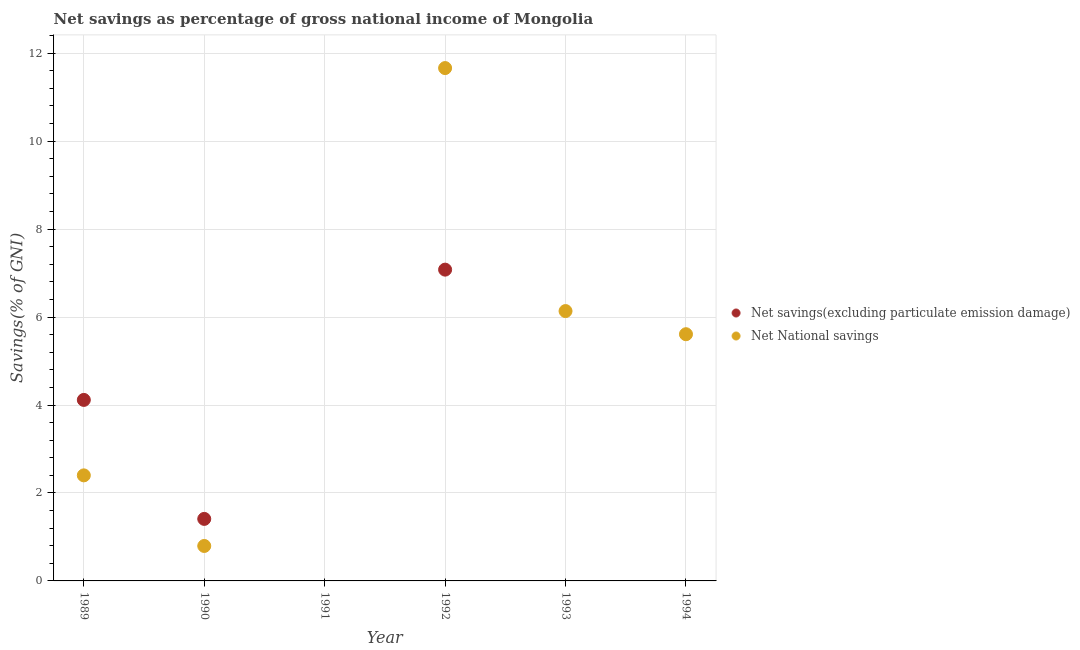Across all years, what is the maximum net savings(excluding particulate emission damage)?
Provide a succinct answer. 7.08. What is the total net national savings in the graph?
Your response must be concise. 26.6. What is the difference between the net national savings in 1990 and that in 1994?
Provide a short and direct response. -4.82. What is the difference between the net national savings in 1989 and the net savings(excluding particulate emission damage) in 1991?
Ensure brevity in your answer.  2.4. What is the average net savings(excluding particulate emission damage) per year?
Ensure brevity in your answer.  2.1. In the year 1992, what is the difference between the net national savings and net savings(excluding particulate emission damage)?
Your answer should be very brief. 4.58. In how many years, is the net national savings greater than 7.2 %?
Give a very brief answer. 1. What is the ratio of the net national savings in 1989 to that in 1992?
Your answer should be compact. 0.21. Is the net national savings in 1989 less than that in 1992?
Your answer should be compact. Yes. What is the difference between the highest and the second highest net savings(excluding particulate emission damage)?
Your answer should be very brief. 2.96. What is the difference between the highest and the lowest net national savings?
Your response must be concise. 11.66. In how many years, is the net national savings greater than the average net national savings taken over all years?
Make the answer very short. 3. Does the net savings(excluding particulate emission damage) monotonically increase over the years?
Your answer should be compact. No. How many dotlines are there?
Offer a terse response. 2. How many years are there in the graph?
Provide a succinct answer. 6. Are the values on the major ticks of Y-axis written in scientific E-notation?
Offer a very short reply. No. Does the graph contain grids?
Give a very brief answer. Yes. How many legend labels are there?
Make the answer very short. 2. What is the title of the graph?
Offer a very short reply. Net savings as percentage of gross national income of Mongolia. Does "% of gross capital formation" appear as one of the legend labels in the graph?
Keep it short and to the point. No. What is the label or title of the X-axis?
Ensure brevity in your answer.  Year. What is the label or title of the Y-axis?
Your answer should be compact. Savings(% of GNI). What is the Savings(% of GNI) of Net savings(excluding particulate emission damage) in 1989?
Provide a short and direct response. 4.12. What is the Savings(% of GNI) of Net National savings in 1989?
Your answer should be very brief. 2.4. What is the Savings(% of GNI) in Net savings(excluding particulate emission damage) in 1990?
Offer a terse response. 1.41. What is the Savings(% of GNI) of Net National savings in 1990?
Ensure brevity in your answer.  0.79. What is the Savings(% of GNI) of Net savings(excluding particulate emission damage) in 1991?
Offer a terse response. 0. What is the Savings(% of GNI) in Net savings(excluding particulate emission damage) in 1992?
Offer a terse response. 7.08. What is the Savings(% of GNI) of Net National savings in 1992?
Provide a short and direct response. 11.66. What is the Savings(% of GNI) in Net savings(excluding particulate emission damage) in 1993?
Your response must be concise. 0. What is the Savings(% of GNI) of Net National savings in 1993?
Keep it short and to the point. 6.14. What is the Savings(% of GNI) in Net savings(excluding particulate emission damage) in 1994?
Offer a very short reply. 0. What is the Savings(% of GNI) of Net National savings in 1994?
Offer a very short reply. 5.61. Across all years, what is the maximum Savings(% of GNI) of Net savings(excluding particulate emission damage)?
Keep it short and to the point. 7.08. Across all years, what is the maximum Savings(% of GNI) of Net National savings?
Give a very brief answer. 11.66. Across all years, what is the minimum Savings(% of GNI) of Net savings(excluding particulate emission damage)?
Offer a very short reply. 0. Across all years, what is the minimum Savings(% of GNI) in Net National savings?
Ensure brevity in your answer.  0. What is the total Savings(% of GNI) of Net savings(excluding particulate emission damage) in the graph?
Provide a short and direct response. 12.61. What is the total Savings(% of GNI) of Net National savings in the graph?
Provide a short and direct response. 26.6. What is the difference between the Savings(% of GNI) of Net savings(excluding particulate emission damage) in 1989 and that in 1990?
Provide a short and direct response. 2.71. What is the difference between the Savings(% of GNI) of Net National savings in 1989 and that in 1990?
Offer a terse response. 1.61. What is the difference between the Savings(% of GNI) in Net savings(excluding particulate emission damage) in 1989 and that in 1992?
Your answer should be compact. -2.96. What is the difference between the Savings(% of GNI) in Net National savings in 1989 and that in 1992?
Your answer should be compact. -9.26. What is the difference between the Savings(% of GNI) of Net National savings in 1989 and that in 1993?
Your answer should be very brief. -3.74. What is the difference between the Savings(% of GNI) of Net National savings in 1989 and that in 1994?
Offer a terse response. -3.21. What is the difference between the Savings(% of GNI) in Net savings(excluding particulate emission damage) in 1990 and that in 1992?
Keep it short and to the point. -5.67. What is the difference between the Savings(% of GNI) in Net National savings in 1990 and that in 1992?
Your answer should be very brief. -10.87. What is the difference between the Savings(% of GNI) of Net National savings in 1990 and that in 1993?
Provide a short and direct response. -5.34. What is the difference between the Savings(% of GNI) of Net National savings in 1990 and that in 1994?
Provide a succinct answer. -4.82. What is the difference between the Savings(% of GNI) of Net National savings in 1992 and that in 1993?
Make the answer very short. 5.53. What is the difference between the Savings(% of GNI) in Net National savings in 1992 and that in 1994?
Provide a succinct answer. 6.05. What is the difference between the Savings(% of GNI) in Net National savings in 1993 and that in 1994?
Make the answer very short. 0.53. What is the difference between the Savings(% of GNI) of Net savings(excluding particulate emission damage) in 1989 and the Savings(% of GNI) of Net National savings in 1990?
Offer a very short reply. 3.32. What is the difference between the Savings(% of GNI) in Net savings(excluding particulate emission damage) in 1989 and the Savings(% of GNI) in Net National savings in 1992?
Your response must be concise. -7.55. What is the difference between the Savings(% of GNI) of Net savings(excluding particulate emission damage) in 1989 and the Savings(% of GNI) of Net National savings in 1993?
Give a very brief answer. -2.02. What is the difference between the Savings(% of GNI) in Net savings(excluding particulate emission damage) in 1989 and the Savings(% of GNI) in Net National savings in 1994?
Your answer should be compact. -1.49. What is the difference between the Savings(% of GNI) in Net savings(excluding particulate emission damage) in 1990 and the Savings(% of GNI) in Net National savings in 1992?
Your response must be concise. -10.25. What is the difference between the Savings(% of GNI) in Net savings(excluding particulate emission damage) in 1990 and the Savings(% of GNI) in Net National savings in 1993?
Offer a terse response. -4.73. What is the difference between the Savings(% of GNI) of Net savings(excluding particulate emission damage) in 1990 and the Savings(% of GNI) of Net National savings in 1994?
Offer a very short reply. -4.2. What is the difference between the Savings(% of GNI) in Net savings(excluding particulate emission damage) in 1992 and the Savings(% of GNI) in Net National savings in 1993?
Offer a very short reply. 0.94. What is the difference between the Savings(% of GNI) in Net savings(excluding particulate emission damage) in 1992 and the Savings(% of GNI) in Net National savings in 1994?
Ensure brevity in your answer.  1.47. What is the average Savings(% of GNI) in Net savings(excluding particulate emission damage) per year?
Provide a short and direct response. 2.1. What is the average Savings(% of GNI) of Net National savings per year?
Your answer should be very brief. 4.43. In the year 1989, what is the difference between the Savings(% of GNI) in Net savings(excluding particulate emission damage) and Savings(% of GNI) in Net National savings?
Your response must be concise. 1.72. In the year 1990, what is the difference between the Savings(% of GNI) of Net savings(excluding particulate emission damage) and Savings(% of GNI) of Net National savings?
Your answer should be very brief. 0.62. In the year 1992, what is the difference between the Savings(% of GNI) in Net savings(excluding particulate emission damage) and Savings(% of GNI) in Net National savings?
Make the answer very short. -4.58. What is the ratio of the Savings(% of GNI) of Net savings(excluding particulate emission damage) in 1989 to that in 1990?
Your response must be concise. 2.92. What is the ratio of the Savings(% of GNI) of Net National savings in 1989 to that in 1990?
Your response must be concise. 3.02. What is the ratio of the Savings(% of GNI) in Net savings(excluding particulate emission damage) in 1989 to that in 1992?
Keep it short and to the point. 0.58. What is the ratio of the Savings(% of GNI) of Net National savings in 1989 to that in 1992?
Provide a short and direct response. 0.21. What is the ratio of the Savings(% of GNI) in Net National savings in 1989 to that in 1993?
Provide a succinct answer. 0.39. What is the ratio of the Savings(% of GNI) of Net National savings in 1989 to that in 1994?
Provide a succinct answer. 0.43. What is the ratio of the Savings(% of GNI) in Net savings(excluding particulate emission damage) in 1990 to that in 1992?
Provide a short and direct response. 0.2. What is the ratio of the Savings(% of GNI) in Net National savings in 1990 to that in 1992?
Your answer should be very brief. 0.07. What is the ratio of the Savings(% of GNI) of Net National savings in 1990 to that in 1993?
Keep it short and to the point. 0.13. What is the ratio of the Savings(% of GNI) of Net National savings in 1990 to that in 1994?
Your answer should be compact. 0.14. What is the ratio of the Savings(% of GNI) of Net National savings in 1992 to that in 1993?
Your response must be concise. 1.9. What is the ratio of the Savings(% of GNI) of Net National savings in 1992 to that in 1994?
Keep it short and to the point. 2.08. What is the ratio of the Savings(% of GNI) in Net National savings in 1993 to that in 1994?
Ensure brevity in your answer.  1.09. What is the difference between the highest and the second highest Savings(% of GNI) in Net savings(excluding particulate emission damage)?
Ensure brevity in your answer.  2.96. What is the difference between the highest and the second highest Savings(% of GNI) in Net National savings?
Your response must be concise. 5.53. What is the difference between the highest and the lowest Savings(% of GNI) in Net savings(excluding particulate emission damage)?
Make the answer very short. 7.08. What is the difference between the highest and the lowest Savings(% of GNI) of Net National savings?
Provide a short and direct response. 11.66. 